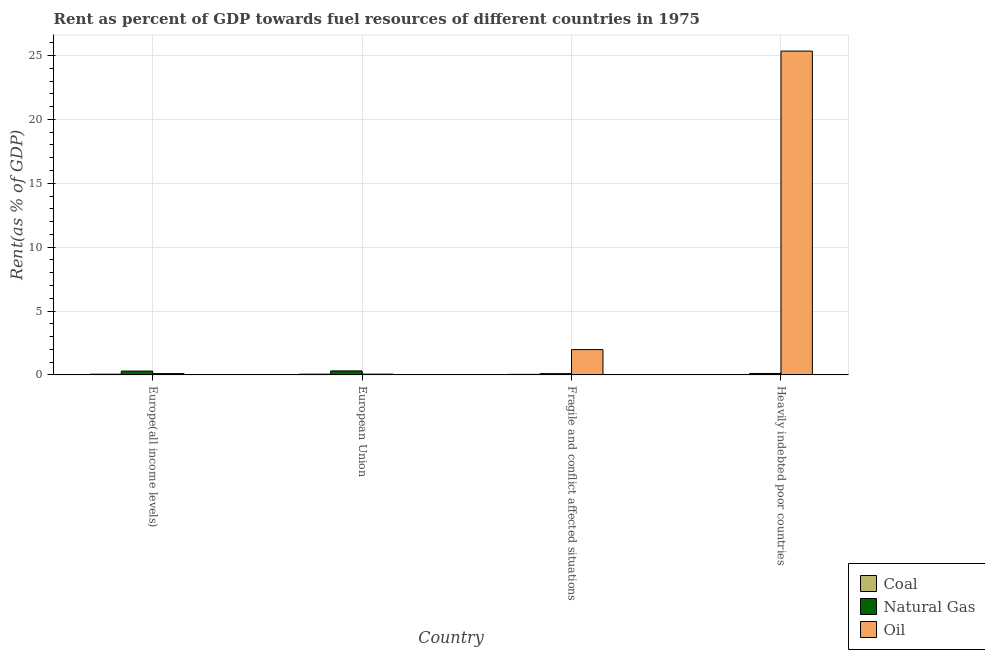How many groups of bars are there?
Make the answer very short. 4. Are the number of bars on each tick of the X-axis equal?
Offer a terse response. Yes. How many bars are there on the 1st tick from the right?
Give a very brief answer. 3. What is the label of the 3rd group of bars from the left?
Provide a short and direct response. Fragile and conflict affected situations. What is the rent towards oil in European Union?
Offer a terse response. 0.06. Across all countries, what is the maximum rent towards oil?
Ensure brevity in your answer.  25.35. Across all countries, what is the minimum rent towards oil?
Provide a short and direct response. 0.06. In which country was the rent towards oil maximum?
Offer a very short reply. Heavily indebted poor countries. In which country was the rent towards coal minimum?
Provide a succinct answer. Heavily indebted poor countries. What is the total rent towards coal in the graph?
Give a very brief answer. 0.17. What is the difference between the rent towards natural gas in Europe(all income levels) and that in European Union?
Your response must be concise. -0.01. What is the difference between the rent towards natural gas in Heavily indebted poor countries and the rent towards coal in Fragile and conflict affected situations?
Give a very brief answer. 0.07. What is the average rent towards oil per country?
Make the answer very short. 6.87. What is the difference between the rent towards oil and rent towards natural gas in Europe(all income levels)?
Give a very brief answer. -0.2. What is the ratio of the rent towards oil in Fragile and conflict affected situations to that in Heavily indebted poor countries?
Offer a very short reply. 0.08. Is the rent towards coal in Europe(all income levels) less than that in Heavily indebted poor countries?
Your response must be concise. No. Is the difference between the rent towards coal in European Union and Heavily indebted poor countries greater than the difference between the rent towards oil in European Union and Heavily indebted poor countries?
Ensure brevity in your answer.  Yes. What is the difference between the highest and the second highest rent towards natural gas?
Your response must be concise. 0.01. What is the difference between the highest and the lowest rent towards coal?
Ensure brevity in your answer.  0.05. What does the 2nd bar from the left in Heavily indebted poor countries represents?
Provide a succinct answer. Natural Gas. What does the 2nd bar from the right in Fragile and conflict affected situations represents?
Your answer should be compact. Natural Gas. How many bars are there?
Keep it short and to the point. 12. How many countries are there in the graph?
Give a very brief answer. 4. Are the values on the major ticks of Y-axis written in scientific E-notation?
Make the answer very short. No. Does the graph contain grids?
Your answer should be very brief. Yes. Where does the legend appear in the graph?
Ensure brevity in your answer.  Bottom right. How many legend labels are there?
Give a very brief answer. 3. How are the legend labels stacked?
Your answer should be compact. Vertical. What is the title of the graph?
Ensure brevity in your answer.  Rent as percent of GDP towards fuel resources of different countries in 1975. Does "Machinery" appear as one of the legend labels in the graph?
Your response must be concise. No. What is the label or title of the X-axis?
Provide a succinct answer. Country. What is the label or title of the Y-axis?
Give a very brief answer. Rent(as % of GDP). What is the Rent(as % of GDP) of Coal in Europe(all income levels)?
Offer a terse response. 0.06. What is the Rent(as % of GDP) in Natural Gas in Europe(all income levels)?
Provide a succinct answer. 0.3. What is the Rent(as % of GDP) of Oil in Europe(all income levels)?
Make the answer very short. 0.1. What is the Rent(as % of GDP) of Coal in European Union?
Provide a short and direct response. 0.06. What is the Rent(as % of GDP) in Natural Gas in European Union?
Make the answer very short. 0.31. What is the Rent(as % of GDP) of Oil in European Union?
Keep it short and to the point. 0.06. What is the Rent(as % of GDP) in Coal in Fragile and conflict affected situations?
Your answer should be very brief. 0.04. What is the Rent(as % of GDP) of Natural Gas in Fragile and conflict affected situations?
Offer a terse response. 0.1. What is the Rent(as % of GDP) of Oil in Fragile and conflict affected situations?
Provide a succinct answer. 1.98. What is the Rent(as % of GDP) in Coal in Heavily indebted poor countries?
Provide a succinct answer. 0.01. What is the Rent(as % of GDP) of Natural Gas in Heavily indebted poor countries?
Offer a terse response. 0.11. What is the Rent(as % of GDP) of Oil in Heavily indebted poor countries?
Make the answer very short. 25.35. Across all countries, what is the maximum Rent(as % of GDP) in Coal?
Provide a succinct answer. 0.06. Across all countries, what is the maximum Rent(as % of GDP) in Natural Gas?
Offer a terse response. 0.31. Across all countries, what is the maximum Rent(as % of GDP) in Oil?
Offer a terse response. 25.35. Across all countries, what is the minimum Rent(as % of GDP) of Coal?
Keep it short and to the point. 0.01. Across all countries, what is the minimum Rent(as % of GDP) of Natural Gas?
Give a very brief answer. 0.1. Across all countries, what is the minimum Rent(as % of GDP) of Oil?
Your response must be concise. 0.06. What is the total Rent(as % of GDP) of Coal in the graph?
Give a very brief answer. 0.17. What is the total Rent(as % of GDP) of Natural Gas in the graph?
Your response must be concise. 0.83. What is the total Rent(as % of GDP) in Oil in the graph?
Ensure brevity in your answer.  27.49. What is the difference between the Rent(as % of GDP) in Coal in Europe(all income levels) and that in European Union?
Ensure brevity in your answer.  -0. What is the difference between the Rent(as % of GDP) in Natural Gas in Europe(all income levels) and that in European Union?
Your answer should be compact. -0.01. What is the difference between the Rent(as % of GDP) in Oil in Europe(all income levels) and that in European Union?
Give a very brief answer. 0.04. What is the difference between the Rent(as % of GDP) of Coal in Europe(all income levels) and that in Fragile and conflict affected situations?
Your answer should be very brief. 0.01. What is the difference between the Rent(as % of GDP) of Natural Gas in Europe(all income levels) and that in Fragile and conflict affected situations?
Keep it short and to the point. 0.2. What is the difference between the Rent(as % of GDP) of Oil in Europe(all income levels) and that in Fragile and conflict affected situations?
Offer a very short reply. -1.88. What is the difference between the Rent(as % of GDP) of Coal in Europe(all income levels) and that in Heavily indebted poor countries?
Offer a terse response. 0.04. What is the difference between the Rent(as % of GDP) in Natural Gas in Europe(all income levels) and that in Heavily indebted poor countries?
Offer a very short reply. 0.19. What is the difference between the Rent(as % of GDP) in Oil in Europe(all income levels) and that in Heavily indebted poor countries?
Provide a short and direct response. -25.25. What is the difference between the Rent(as % of GDP) of Coal in European Union and that in Fragile and conflict affected situations?
Keep it short and to the point. 0.01. What is the difference between the Rent(as % of GDP) in Natural Gas in European Union and that in Fragile and conflict affected situations?
Your response must be concise. 0.21. What is the difference between the Rent(as % of GDP) in Oil in European Union and that in Fragile and conflict affected situations?
Your response must be concise. -1.92. What is the difference between the Rent(as % of GDP) of Coal in European Union and that in Heavily indebted poor countries?
Ensure brevity in your answer.  0.05. What is the difference between the Rent(as % of GDP) of Natural Gas in European Union and that in Heavily indebted poor countries?
Your response must be concise. 0.2. What is the difference between the Rent(as % of GDP) in Oil in European Union and that in Heavily indebted poor countries?
Your answer should be very brief. -25.29. What is the difference between the Rent(as % of GDP) in Coal in Fragile and conflict affected situations and that in Heavily indebted poor countries?
Provide a succinct answer. 0.03. What is the difference between the Rent(as % of GDP) of Natural Gas in Fragile and conflict affected situations and that in Heavily indebted poor countries?
Your response must be concise. -0.01. What is the difference between the Rent(as % of GDP) in Oil in Fragile and conflict affected situations and that in Heavily indebted poor countries?
Provide a short and direct response. -23.37. What is the difference between the Rent(as % of GDP) in Coal in Europe(all income levels) and the Rent(as % of GDP) in Natural Gas in European Union?
Keep it short and to the point. -0.26. What is the difference between the Rent(as % of GDP) of Coal in Europe(all income levels) and the Rent(as % of GDP) of Oil in European Union?
Your answer should be very brief. -0. What is the difference between the Rent(as % of GDP) in Natural Gas in Europe(all income levels) and the Rent(as % of GDP) in Oil in European Union?
Give a very brief answer. 0.24. What is the difference between the Rent(as % of GDP) of Coal in Europe(all income levels) and the Rent(as % of GDP) of Natural Gas in Fragile and conflict affected situations?
Give a very brief answer. -0.04. What is the difference between the Rent(as % of GDP) of Coal in Europe(all income levels) and the Rent(as % of GDP) of Oil in Fragile and conflict affected situations?
Offer a very short reply. -1.92. What is the difference between the Rent(as % of GDP) in Natural Gas in Europe(all income levels) and the Rent(as % of GDP) in Oil in Fragile and conflict affected situations?
Your response must be concise. -1.68. What is the difference between the Rent(as % of GDP) of Coal in Europe(all income levels) and the Rent(as % of GDP) of Natural Gas in Heavily indebted poor countries?
Your answer should be very brief. -0.05. What is the difference between the Rent(as % of GDP) in Coal in Europe(all income levels) and the Rent(as % of GDP) in Oil in Heavily indebted poor countries?
Your answer should be compact. -25.29. What is the difference between the Rent(as % of GDP) of Natural Gas in Europe(all income levels) and the Rent(as % of GDP) of Oil in Heavily indebted poor countries?
Provide a short and direct response. -25.05. What is the difference between the Rent(as % of GDP) in Coal in European Union and the Rent(as % of GDP) in Natural Gas in Fragile and conflict affected situations?
Your answer should be compact. -0.04. What is the difference between the Rent(as % of GDP) in Coal in European Union and the Rent(as % of GDP) in Oil in Fragile and conflict affected situations?
Your response must be concise. -1.92. What is the difference between the Rent(as % of GDP) of Natural Gas in European Union and the Rent(as % of GDP) of Oil in Fragile and conflict affected situations?
Provide a succinct answer. -1.67. What is the difference between the Rent(as % of GDP) of Coal in European Union and the Rent(as % of GDP) of Natural Gas in Heavily indebted poor countries?
Your response must be concise. -0.05. What is the difference between the Rent(as % of GDP) of Coal in European Union and the Rent(as % of GDP) of Oil in Heavily indebted poor countries?
Make the answer very short. -25.29. What is the difference between the Rent(as % of GDP) in Natural Gas in European Union and the Rent(as % of GDP) in Oil in Heavily indebted poor countries?
Offer a very short reply. -25.04. What is the difference between the Rent(as % of GDP) of Coal in Fragile and conflict affected situations and the Rent(as % of GDP) of Natural Gas in Heavily indebted poor countries?
Keep it short and to the point. -0.07. What is the difference between the Rent(as % of GDP) in Coal in Fragile and conflict affected situations and the Rent(as % of GDP) in Oil in Heavily indebted poor countries?
Keep it short and to the point. -25.31. What is the difference between the Rent(as % of GDP) in Natural Gas in Fragile and conflict affected situations and the Rent(as % of GDP) in Oil in Heavily indebted poor countries?
Provide a succinct answer. -25.25. What is the average Rent(as % of GDP) in Coal per country?
Keep it short and to the point. 0.04. What is the average Rent(as % of GDP) in Natural Gas per country?
Your answer should be compact. 0.21. What is the average Rent(as % of GDP) of Oil per country?
Provide a short and direct response. 6.87. What is the difference between the Rent(as % of GDP) of Coal and Rent(as % of GDP) of Natural Gas in Europe(all income levels)?
Provide a short and direct response. -0.24. What is the difference between the Rent(as % of GDP) in Coal and Rent(as % of GDP) in Oil in Europe(all income levels)?
Your response must be concise. -0.05. What is the difference between the Rent(as % of GDP) of Natural Gas and Rent(as % of GDP) of Oil in Europe(all income levels)?
Keep it short and to the point. 0.2. What is the difference between the Rent(as % of GDP) of Coal and Rent(as % of GDP) of Natural Gas in European Union?
Provide a short and direct response. -0.26. What is the difference between the Rent(as % of GDP) of Coal and Rent(as % of GDP) of Oil in European Union?
Provide a succinct answer. -0. What is the difference between the Rent(as % of GDP) of Natural Gas and Rent(as % of GDP) of Oil in European Union?
Offer a terse response. 0.25. What is the difference between the Rent(as % of GDP) in Coal and Rent(as % of GDP) in Natural Gas in Fragile and conflict affected situations?
Your answer should be compact. -0.06. What is the difference between the Rent(as % of GDP) in Coal and Rent(as % of GDP) in Oil in Fragile and conflict affected situations?
Give a very brief answer. -1.94. What is the difference between the Rent(as % of GDP) of Natural Gas and Rent(as % of GDP) of Oil in Fragile and conflict affected situations?
Keep it short and to the point. -1.88. What is the difference between the Rent(as % of GDP) in Coal and Rent(as % of GDP) in Natural Gas in Heavily indebted poor countries?
Provide a short and direct response. -0.1. What is the difference between the Rent(as % of GDP) in Coal and Rent(as % of GDP) in Oil in Heavily indebted poor countries?
Your answer should be compact. -25.34. What is the difference between the Rent(as % of GDP) in Natural Gas and Rent(as % of GDP) in Oil in Heavily indebted poor countries?
Your answer should be compact. -25.24. What is the ratio of the Rent(as % of GDP) of Coal in Europe(all income levels) to that in European Union?
Ensure brevity in your answer.  0.98. What is the ratio of the Rent(as % of GDP) of Natural Gas in Europe(all income levels) to that in European Union?
Provide a succinct answer. 0.96. What is the ratio of the Rent(as % of GDP) of Oil in Europe(all income levels) to that in European Union?
Offer a very short reply. 1.74. What is the ratio of the Rent(as % of GDP) of Coal in Europe(all income levels) to that in Fragile and conflict affected situations?
Ensure brevity in your answer.  1.31. What is the ratio of the Rent(as % of GDP) in Natural Gas in Europe(all income levels) to that in Fragile and conflict affected situations?
Provide a succinct answer. 3.02. What is the ratio of the Rent(as % of GDP) of Oil in Europe(all income levels) to that in Fragile and conflict affected situations?
Provide a succinct answer. 0.05. What is the ratio of the Rent(as % of GDP) in Coal in Europe(all income levels) to that in Heavily indebted poor countries?
Offer a very short reply. 4.27. What is the ratio of the Rent(as % of GDP) of Natural Gas in Europe(all income levels) to that in Heavily indebted poor countries?
Provide a succinct answer. 2.68. What is the ratio of the Rent(as % of GDP) of Oil in Europe(all income levels) to that in Heavily indebted poor countries?
Your answer should be very brief. 0. What is the ratio of the Rent(as % of GDP) of Coal in European Union to that in Fragile and conflict affected situations?
Your response must be concise. 1.34. What is the ratio of the Rent(as % of GDP) of Natural Gas in European Union to that in Fragile and conflict affected situations?
Your answer should be compact. 3.15. What is the ratio of the Rent(as % of GDP) of Oil in European Union to that in Fragile and conflict affected situations?
Offer a very short reply. 0.03. What is the ratio of the Rent(as % of GDP) of Coal in European Union to that in Heavily indebted poor countries?
Your response must be concise. 4.37. What is the ratio of the Rent(as % of GDP) of Natural Gas in European Union to that in Heavily indebted poor countries?
Ensure brevity in your answer.  2.79. What is the ratio of the Rent(as % of GDP) of Oil in European Union to that in Heavily indebted poor countries?
Provide a succinct answer. 0. What is the ratio of the Rent(as % of GDP) in Coal in Fragile and conflict affected situations to that in Heavily indebted poor countries?
Offer a very short reply. 3.25. What is the ratio of the Rent(as % of GDP) of Natural Gas in Fragile and conflict affected situations to that in Heavily indebted poor countries?
Give a very brief answer. 0.89. What is the ratio of the Rent(as % of GDP) of Oil in Fragile and conflict affected situations to that in Heavily indebted poor countries?
Offer a very short reply. 0.08. What is the difference between the highest and the second highest Rent(as % of GDP) in Coal?
Your answer should be compact. 0. What is the difference between the highest and the second highest Rent(as % of GDP) in Natural Gas?
Ensure brevity in your answer.  0.01. What is the difference between the highest and the second highest Rent(as % of GDP) in Oil?
Keep it short and to the point. 23.37. What is the difference between the highest and the lowest Rent(as % of GDP) in Coal?
Ensure brevity in your answer.  0.05. What is the difference between the highest and the lowest Rent(as % of GDP) of Natural Gas?
Keep it short and to the point. 0.21. What is the difference between the highest and the lowest Rent(as % of GDP) in Oil?
Make the answer very short. 25.29. 